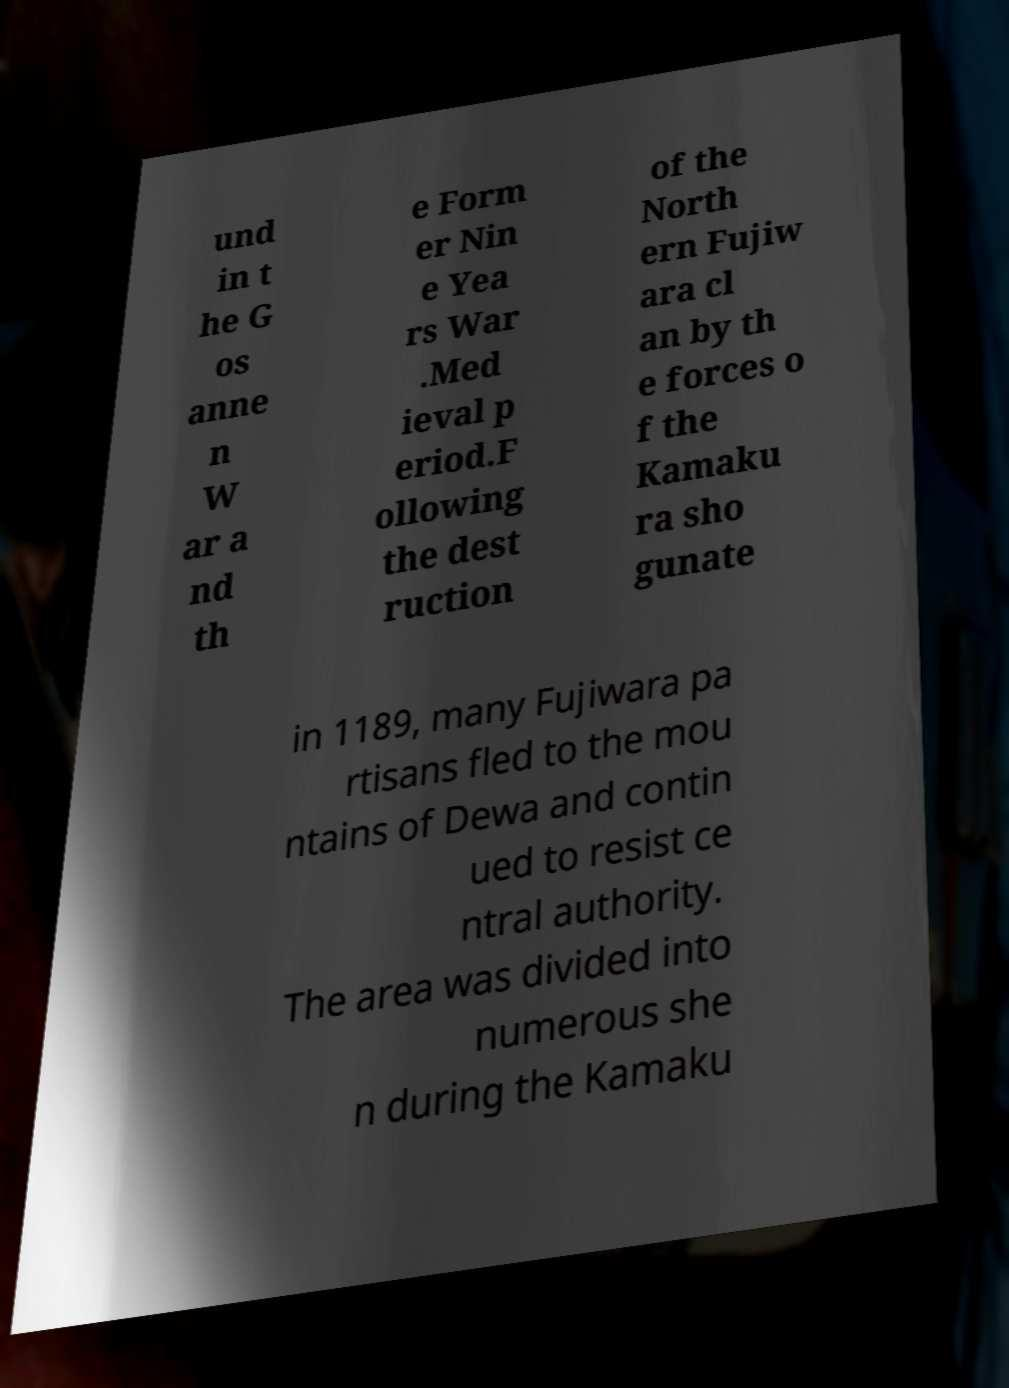What messages or text are displayed in this image? I need them in a readable, typed format. und in t he G os anne n W ar a nd th e Form er Nin e Yea rs War .Med ieval p eriod.F ollowing the dest ruction of the North ern Fujiw ara cl an by th e forces o f the Kamaku ra sho gunate in 1189, many Fujiwara pa rtisans fled to the mou ntains of Dewa and contin ued to resist ce ntral authority. The area was divided into numerous she n during the Kamaku 